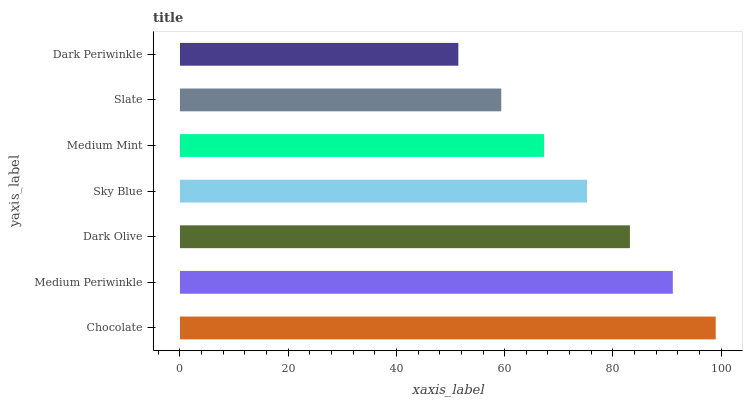Is Dark Periwinkle the minimum?
Answer yes or no. Yes. Is Chocolate the maximum?
Answer yes or no. Yes. Is Medium Periwinkle the minimum?
Answer yes or no. No. Is Medium Periwinkle the maximum?
Answer yes or no. No. Is Chocolate greater than Medium Periwinkle?
Answer yes or no. Yes. Is Medium Periwinkle less than Chocolate?
Answer yes or no. Yes. Is Medium Periwinkle greater than Chocolate?
Answer yes or no. No. Is Chocolate less than Medium Periwinkle?
Answer yes or no. No. Is Sky Blue the high median?
Answer yes or no. Yes. Is Sky Blue the low median?
Answer yes or no. Yes. Is Slate the high median?
Answer yes or no. No. Is Chocolate the low median?
Answer yes or no. No. 